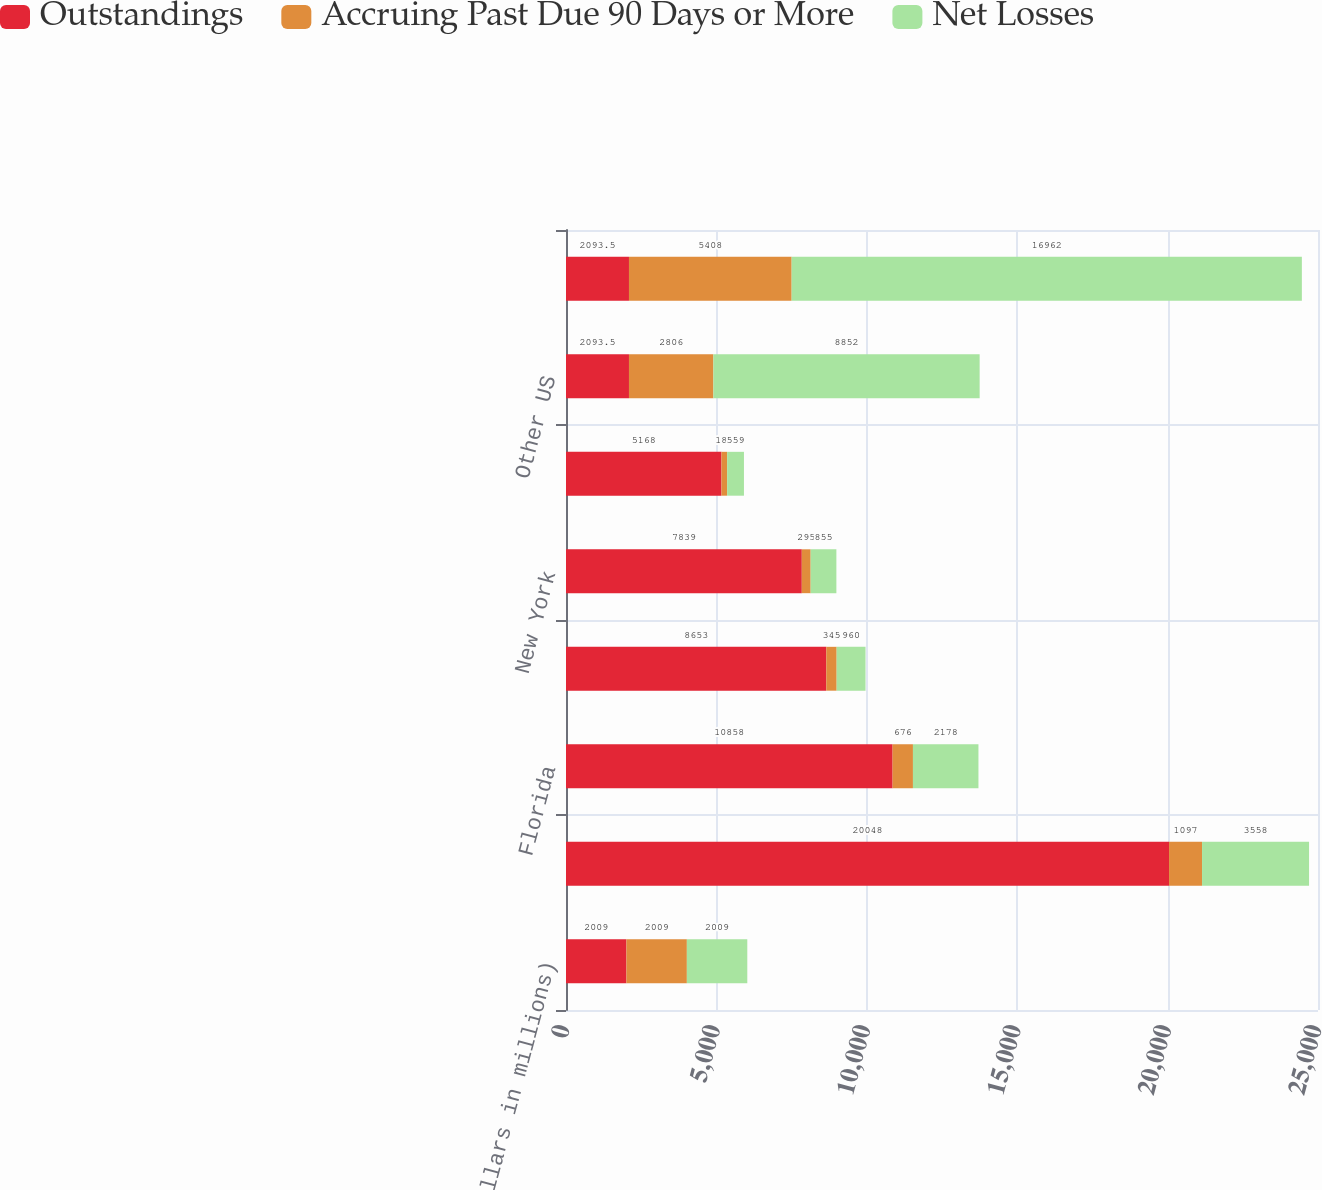Convert chart. <chart><loc_0><loc_0><loc_500><loc_500><stacked_bar_chart><ecel><fcel>(Dollars in millions)<fcel>California<fcel>Florida<fcel>Texas<fcel>New York<fcel>New Jersey<fcel>Other US<fcel>Total credit card - domestic<nl><fcel>Outstandings<fcel>2009<fcel>20048<fcel>10858<fcel>8653<fcel>7839<fcel>5168<fcel>2093.5<fcel>2093.5<nl><fcel>Accruing Past Due 90 Days or More<fcel>2009<fcel>1097<fcel>676<fcel>345<fcel>295<fcel>189<fcel>2806<fcel>5408<nl><fcel>Net Losses<fcel>2009<fcel>3558<fcel>2178<fcel>960<fcel>855<fcel>559<fcel>8852<fcel>16962<nl></chart> 